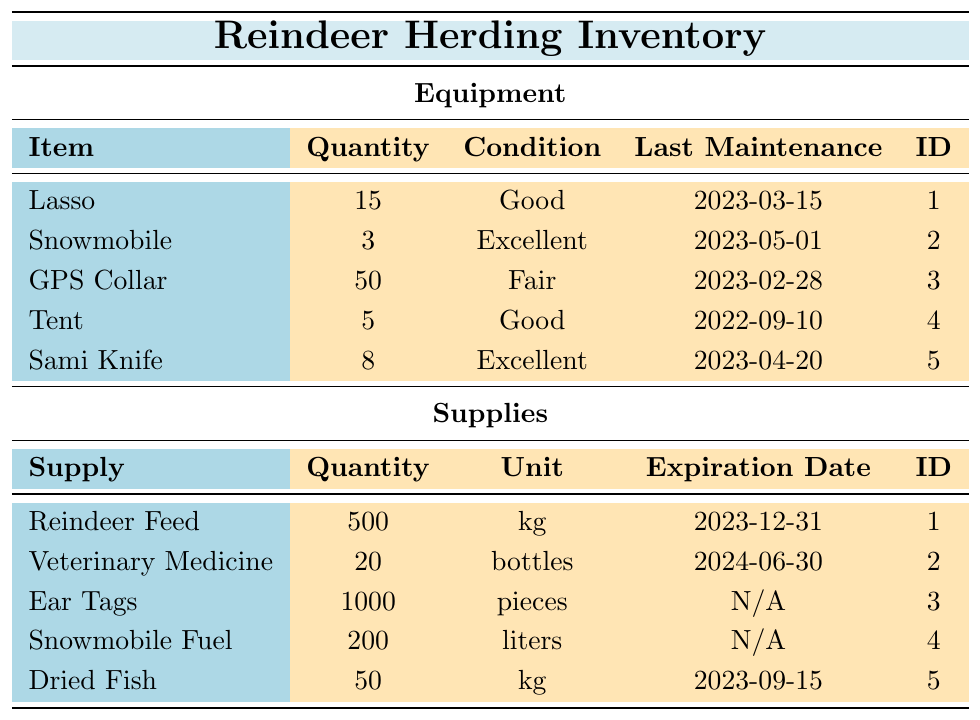What is the quantity of GPS Collars in the inventory? The data in the table shows that there are 50 GPS Collars listed under the equipment inventory.
Answer: 50 What is the condition of the Snowmobile? According to the table, the Snowmobile is noted as being in Excellent condition.
Answer: Excellent How many items in total are there in the equipment inventory? To find the total, we count the number of items listed: Lasso, Snowmobile, GPS Collar, Tent, and Sami Knife, which gives us 5 items in total.
Answer: 5 How many kilograms of Reindeer Feed do we have? The table shows that there are 500 kg of Reindeer Feed in the supplies inventory.
Answer: 500 kg Is the condition of the Sami Knife classified as Fair? The table states that the condition of the Sami Knife is Excellent, therefore it is not classified as Fair.
Answer: No What is the total quantity of supplies (in pieces) excluding expiration dates? We add the quantities of supplies that have no expiration dates: Ear Tags (1000 pieces) and Snowmobile Fuel (200 liters). Therefore, the total is 1000 + 200 = 1200.
Answer: 1200 When was the last maintenance performed on the Tent? The table specifies that the last maintenance on the Tent was performed on September 10, 2022.
Answer: 2022-09-10 How many liters of Snowmobile Fuel do we have compared to the quantity of Dried Fish? The quantity of Snowmobile Fuel is 200 liters and the quantity of Dried Fish is 50 kg. There are more liters of Snowmobile Fuel than kilograms of Dried Fish (200 > 50).
Answer: Yes, more fuel What is the expiration date for Veterinary Medicine? The table indicates that the expiration date for Veterinary Medicine is June 30, 2024.
Answer: 2024-06-30 What is the average quantity of equipment items in good or excellent condition? There are 3 items (Lasso, Snowmobile, and Sami Knife) in Good or Excellent condition totaling a quantity of 15 + 3 + 8 = 26. The average is 26/3 = approximately 8.67.
Answer: 8.67 